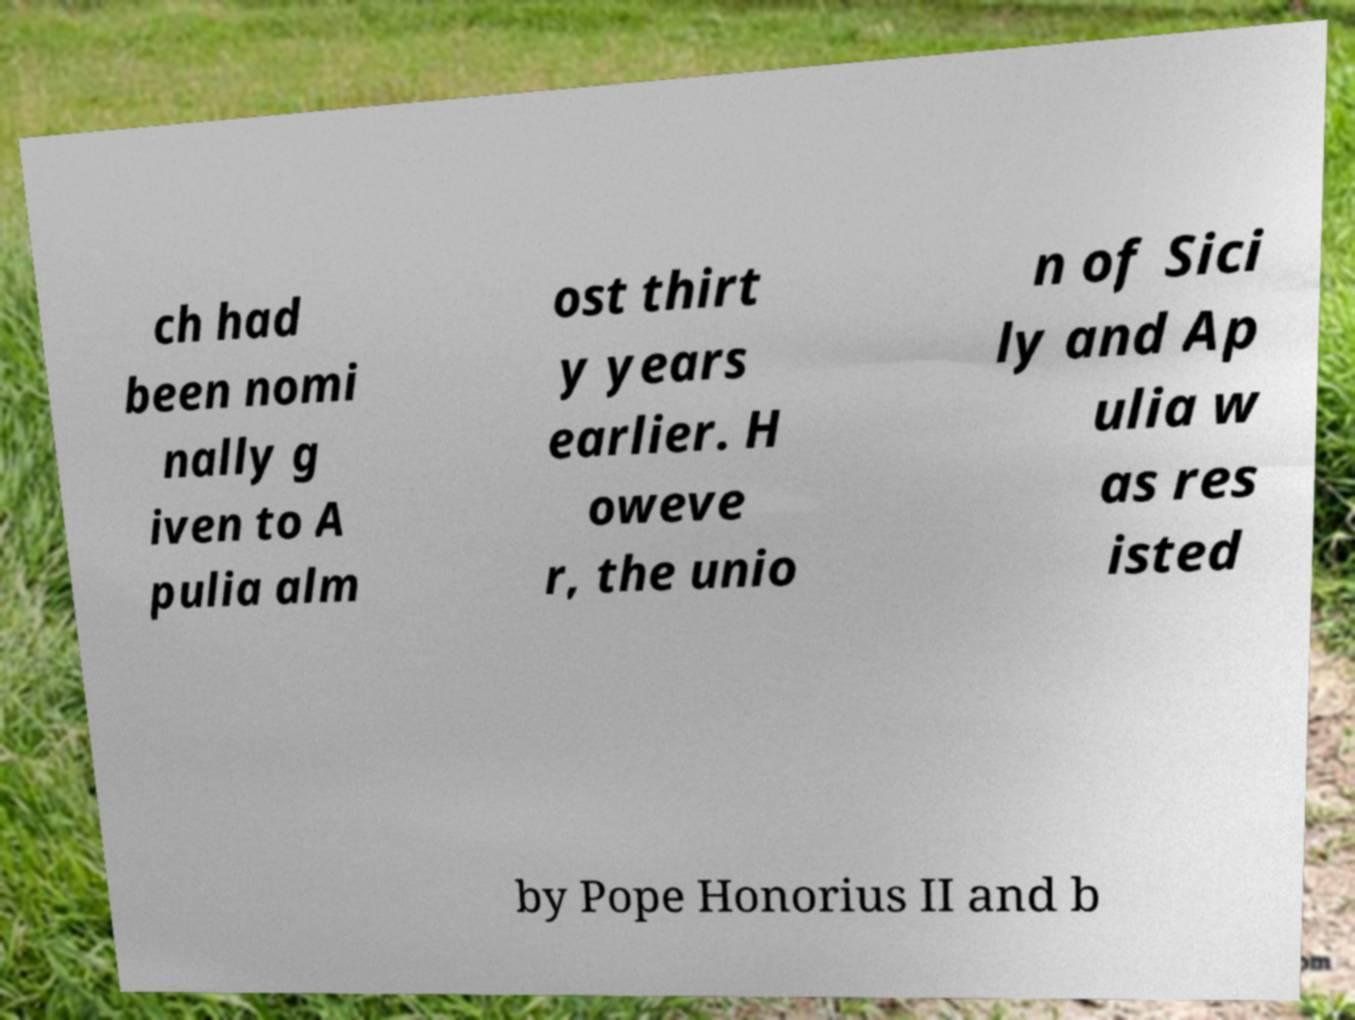Could you extract and type out the text from this image? ch had been nomi nally g iven to A pulia alm ost thirt y years earlier. H oweve r, the unio n of Sici ly and Ap ulia w as res isted by Pope Honorius II and b 